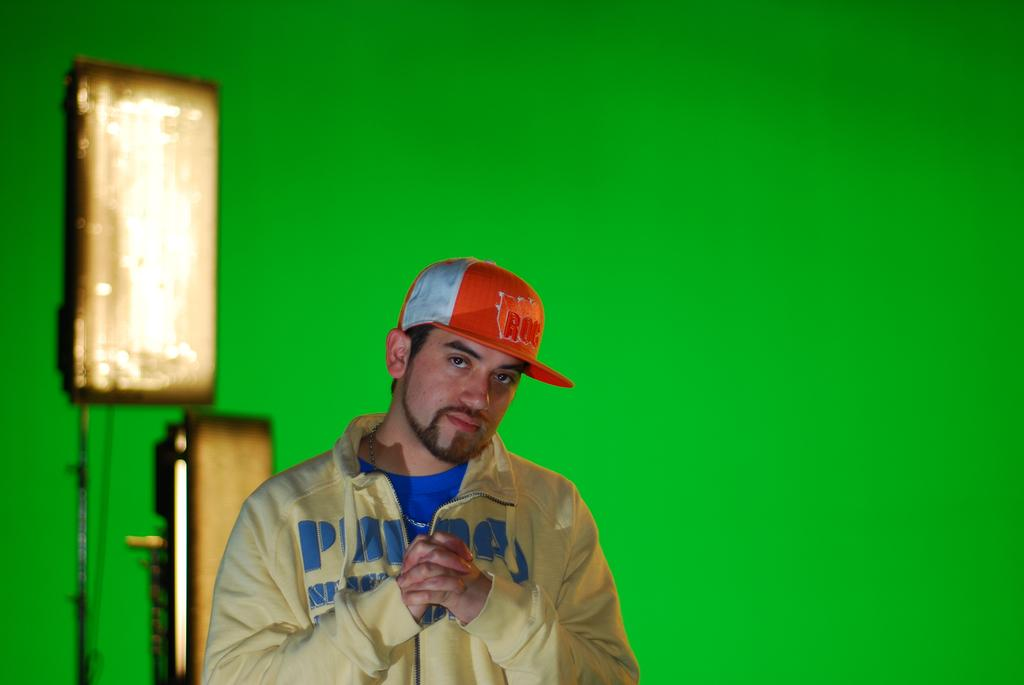What is the main subject of the image? There is a man standing in the image. What is the man doing in the image? The man is posing for a photo. What color is the background in the image? The background in the image is green. How many birds are flying in the image? There are no birds visible in the image. Is there a woman standing next to the man in the image? The image only shows a man standing in the image, so there is no woman present. 